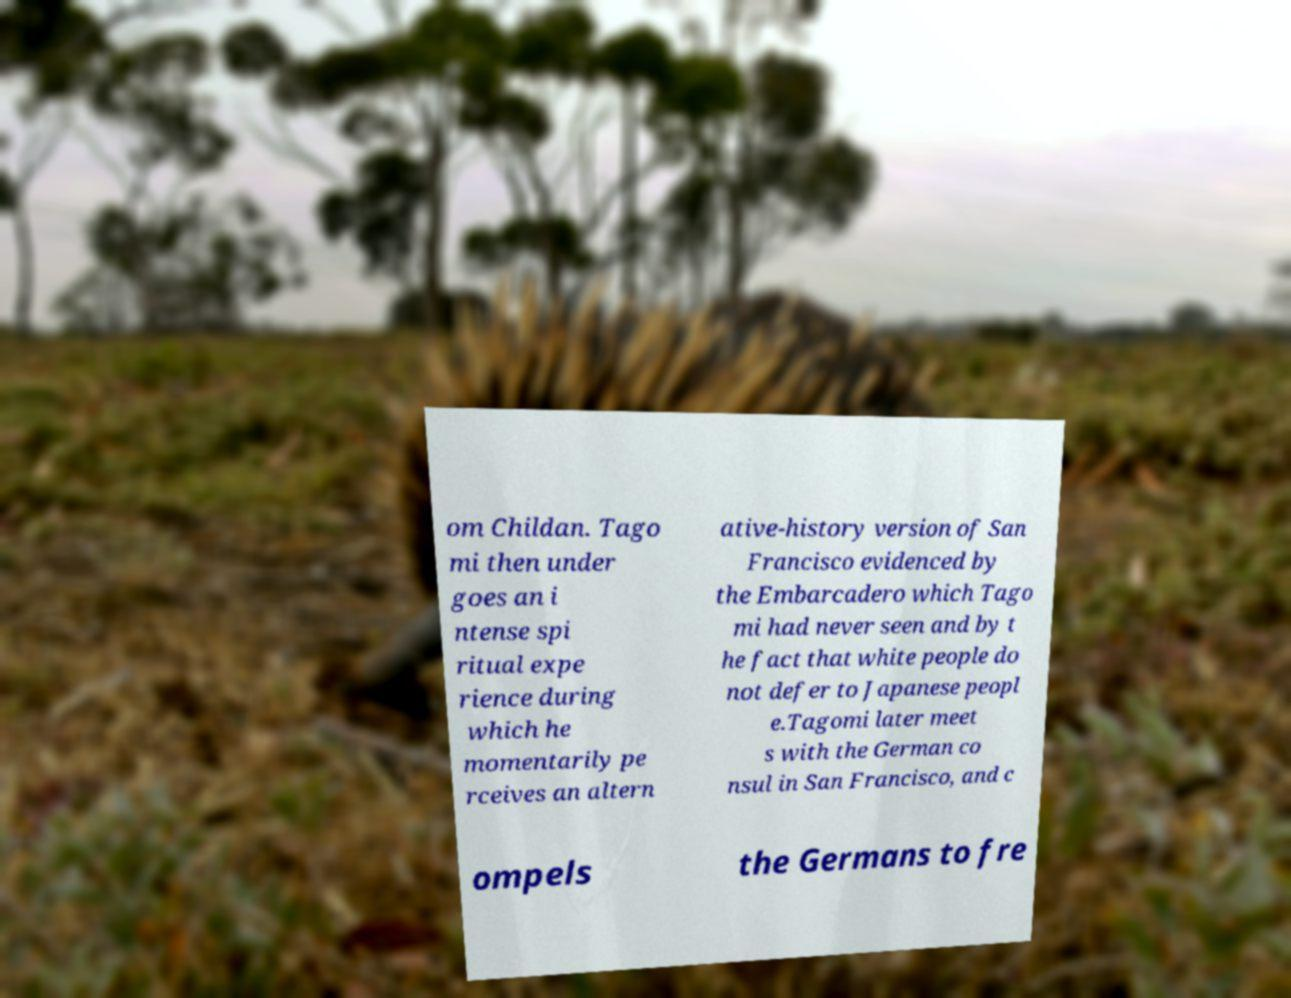I need the written content from this picture converted into text. Can you do that? om Childan. Tago mi then under goes an i ntense spi ritual expe rience during which he momentarily pe rceives an altern ative-history version of San Francisco evidenced by the Embarcadero which Tago mi had never seen and by t he fact that white people do not defer to Japanese peopl e.Tagomi later meet s with the German co nsul in San Francisco, and c ompels the Germans to fre 